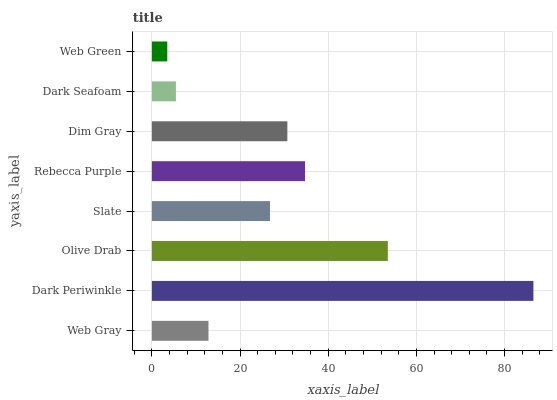Is Web Green the minimum?
Answer yes or no. Yes. Is Dark Periwinkle the maximum?
Answer yes or no. Yes. Is Olive Drab the minimum?
Answer yes or no. No. Is Olive Drab the maximum?
Answer yes or no. No. Is Dark Periwinkle greater than Olive Drab?
Answer yes or no. Yes. Is Olive Drab less than Dark Periwinkle?
Answer yes or no. Yes. Is Olive Drab greater than Dark Periwinkle?
Answer yes or no. No. Is Dark Periwinkle less than Olive Drab?
Answer yes or no. No. Is Dim Gray the high median?
Answer yes or no. Yes. Is Slate the low median?
Answer yes or no. Yes. Is Web Green the high median?
Answer yes or no. No. Is Dim Gray the low median?
Answer yes or no. No. 